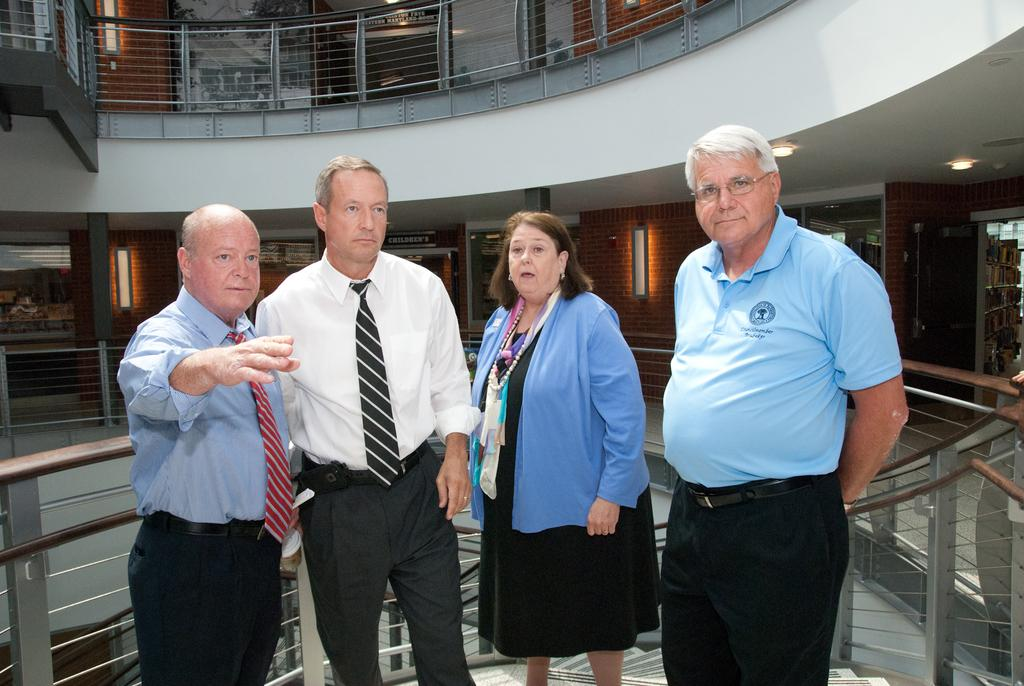How many people are in the image? There are four people standing in the middle of the image. What is the surface on which the people are standing? The people are standing on the floor. What can be seen in the background of the image? In the background of the image, there is a metal grill, doors, a photo frame, a wall, and lights. What type of crowd can be heard in the background of the image? There is no crowd present in the image, and therefore no sound can be heard. 